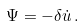<formula> <loc_0><loc_0><loc_500><loc_500>\Psi = - \delta \dot { u } \, .</formula> 